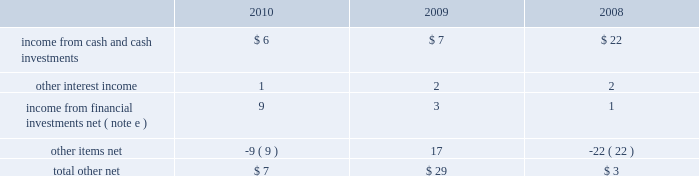Segment information 2013 ( concluded ) ( 1 ) included in net sales were export sales from the u.s .
Of $ 246 million , $ 277 million and $ 275 million in 2010 , 2009 and 2008 , respectively .
( 2 ) intra-company sales between segments represented approximately two percent of net sales in 2010 , three percent of net sales in 2009 and one percent of net sales in 2008 .
( 3 ) included in net sales were sales to one customer of $ 1993 million , $ 2053 million and $ 2058 million in 2010 , 2009 and 2008 , respectively .
Such net sales were included in the following segments : cabinets and related products , plumbing products , decorative architectural products and other specialty products .
( 4 ) net sales from the company 2019s operations in the u.s .
Were $ 5618 million , $ 5952 million and $ 7150 million in 2010 , 2009 and 2008 , respectively .
( 5 ) net sales , operating ( loss ) profit , property additions and depreciation and amortization expense for 2010 , 2009 and 2008 excluded the results of businesses reported as discontinued operations in 2010 , 2009 and 2008 .
( 6 ) included in segment operating ( loss ) profit for 2010 were impairment charges for goodwill and other intangible assets as follows : plumbing products 2013 $ 1 million ; and installation and other services 2013 $ 720 million .
Included in segment operating profit ( loss ) for 2009 were impairment charges for goodwill as follows : plumbing products 2013 $ 39 million ; other specialty products 2013 $ 223 million .
Included in segment operating profit ( loss ) for 2008 were impairment charges for goodwill and other intangible assets as follows : cabinets and related products 2013 $ 59 million ; plumbing products 2013 $ 203 million ; installation and other services 2013 $ 52 million ; and other specialty products 2013 $ 153 million .
( 7 ) general corporate expense , net included those expenses not specifically attributable to the company 2019s segments .
( 8 ) during 2009 , the company recognized a curtailment loss related to the plan to freeze all future benefit accruals beginning january 1 , 2010 under substantially all of the company 2019s domestic qualified and non-qualified defined-benefit pension plans .
See note m to the consolidated financial statements .
( 9 ) the charge for litigation settlement in 2009 relates to a business unit in the cabinets and related products segment .
The charge for litigation settlement in 2008 relates to a business unit in the installation and other services segment .
( 10 ) see note l to the consolidated financial statements .
( 11 ) long-lived assets of the company 2019s operations in the u.s .
And europe were $ 3684 million and $ 617 million , $ 4628 million and $ 690 million , and $ 4887 million and $ 770 million at december 31 , 2010 , 2009 and 2008 , respectively .
( 12 ) segment assets for 2009 and 2008 excluded the assets of businesses reported as discontinued operations .
Other income ( expense ) , net other , net , which is included in other income ( expense ) , net , was as follows , in millions: .
Masco corporation notes to consolidated financial statements 2014 ( continued ) .
What was the increase observed in the export sales among net sales during 2008 and 2009? 
Rationale: it is the number of sales in 2009 divided by the 2008's , then subtracted 1 and turned into a percentage.\\n
Computations: ((277 / 275) - 1)
Answer: 0.00727. Segment information 2013 ( concluded ) ( 1 ) included in net sales were export sales from the u.s .
Of $ 246 million , $ 277 million and $ 275 million in 2010 , 2009 and 2008 , respectively .
( 2 ) intra-company sales between segments represented approximately two percent of net sales in 2010 , three percent of net sales in 2009 and one percent of net sales in 2008 .
( 3 ) included in net sales were sales to one customer of $ 1993 million , $ 2053 million and $ 2058 million in 2010 , 2009 and 2008 , respectively .
Such net sales were included in the following segments : cabinets and related products , plumbing products , decorative architectural products and other specialty products .
( 4 ) net sales from the company 2019s operations in the u.s .
Were $ 5618 million , $ 5952 million and $ 7150 million in 2010 , 2009 and 2008 , respectively .
( 5 ) net sales , operating ( loss ) profit , property additions and depreciation and amortization expense for 2010 , 2009 and 2008 excluded the results of businesses reported as discontinued operations in 2010 , 2009 and 2008 .
( 6 ) included in segment operating ( loss ) profit for 2010 were impairment charges for goodwill and other intangible assets as follows : plumbing products 2013 $ 1 million ; and installation and other services 2013 $ 720 million .
Included in segment operating profit ( loss ) for 2009 were impairment charges for goodwill as follows : plumbing products 2013 $ 39 million ; other specialty products 2013 $ 223 million .
Included in segment operating profit ( loss ) for 2008 were impairment charges for goodwill and other intangible assets as follows : cabinets and related products 2013 $ 59 million ; plumbing products 2013 $ 203 million ; installation and other services 2013 $ 52 million ; and other specialty products 2013 $ 153 million .
( 7 ) general corporate expense , net included those expenses not specifically attributable to the company 2019s segments .
( 8 ) during 2009 , the company recognized a curtailment loss related to the plan to freeze all future benefit accruals beginning january 1 , 2010 under substantially all of the company 2019s domestic qualified and non-qualified defined-benefit pension plans .
See note m to the consolidated financial statements .
( 9 ) the charge for litigation settlement in 2009 relates to a business unit in the cabinets and related products segment .
The charge for litigation settlement in 2008 relates to a business unit in the installation and other services segment .
( 10 ) see note l to the consolidated financial statements .
( 11 ) long-lived assets of the company 2019s operations in the u.s .
And europe were $ 3684 million and $ 617 million , $ 4628 million and $ 690 million , and $ 4887 million and $ 770 million at december 31 , 2010 , 2009 and 2008 , respectively .
( 12 ) segment assets for 2009 and 2008 excluded the assets of businesses reported as discontinued operations .
Other income ( expense ) , net other , net , which is included in other income ( expense ) , net , was as follows , in millions: .
Masco corporation notes to consolidated financial statements 2014 ( continued ) .
Considering the years 2008-2010 , what is the average income from cash and cash investments , in millions? 
Rationale: it is the sum of all income from cash and cash investments' value for these years , then divided by three .
Computations: table_average(income from cash and cash investments, none)
Answer: 11.66667. Segment information 2013 ( concluded ) ( 1 ) included in net sales were export sales from the u.s .
Of $ 246 million , $ 277 million and $ 275 million in 2010 , 2009 and 2008 , respectively .
( 2 ) intra-company sales between segments represented approximately two percent of net sales in 2010 , three percent of net sales in 2009 and one percent of net sales in 2008 .
( 3 ) included in net sales were sales to one customer of $ 1993 million , $ 2053 million and $ 2058 million in 2010 , 2009 and 2008 , respectively .
Such net sales were included in the following segments : cabinets and related products , plumbing products , decorative architectural products and other specialty products .
( 4 ) net sales from the company 2019s operations in the u.s .
Were $ 5618 million , $ 5952 million and $ 7150 million in 2010 , 2009 and 2008 , respectively .
( 5 ) net sales , operating ( loss ) profit , property additions and depreciation and amortization expense for 2010 , 2009 and 2008 excluded the results of businesses reported as discontinued operations in 2010 , 2009 and 2008 .
( 6 ) included in segment operating ( loss ) profit for 2010 were impairment charges for goodwill and other intangible assets as follows : plumbing products 2013 $ 1 million ; and installation and other services 2013 $ 720 million .
Included in segment operating profit ( loss ) for 2009 were impairment charges for goodwill as follows : plumbing products 2013 $ 39 million ; other specialty products 2013 $ 223 million .
Included in segment operating profit ( loss ) for 2008 were impairment charges for goodwill and other intangible assets as follows : cabinets and related products 2013 $ 59 million ; plumbing products 2013 $ 203 million ; installation and other services 2013 $ 52 million ; and other specialty products 2013 $ 153 million .
( 7 ) general corporate expense , net included those expenses not specifically attributable to the company 2019s segments .
( 8 ) during 2009 , the company recognized a curtailment loss related to the plan to freeze all future benefit accruals beginning january 1 , 2010 under substantially all of the company 2019s domestic qualified and non-qualified defined-benefit pension plans .
See note m to the consolidated financial statements .
( 9 ) the charge for litigation settlement in 2009 relates to a business unit in the cabinets and related products segment .
The charge for litigation settlement in 2008 relates to a business unit in the installation and other services segment .
( 10 ) see note l to the consolidated financial statements .
( 11 ) long-lived assets of the company 2019s operations in the u.s .
And europe were $ 3684 million and $ 617 million , $ 4628 million and $ 690 million , and $ 4887 million and $ 770 million at december 31 , 2010 , 2009 and 2008 , respectively .
( 12 ) segment assets for 2009 and 2008 excluded the assets of businesses reported as discontinued operations .
Other income ( expense ) , net other , net , which is included in other income ( expense ) , net , was as follows , in millions: .
Masco corporation notes to consolidated financial statements 2014 ( continued ) .
What was the percentage increase in the income from financial investments net ( note e ) from 2009 to 2010? 
Computations: ((9 - 3) / 3)
Answer: 2.0. 